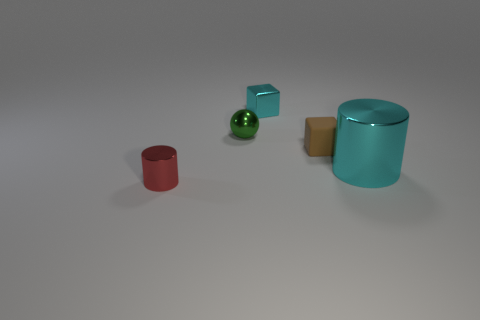Add 1 cyan blocks. How many objects exist? 6 Subtract all spheres. How many objects are left? 4 Subtract 0 brown cylinders. How many objects are left? 5 Subtract all big red cylinders. Subtract all green shiny objects. How many objects are left? 4 Add 3 cyan cubes. How many cyan cubes are left? 4 Add 2 big metallic objects. How many big metallic objects exist? 3 